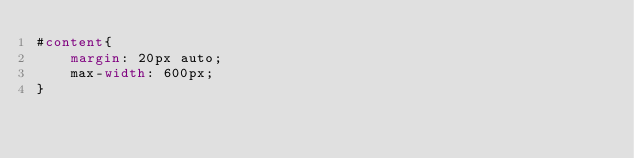<code> <loc_0><loc_0><loc_500><loc_500><_CSS_>#content{
    margin: 20px auto;
    max-width: 600px;
}</code> 